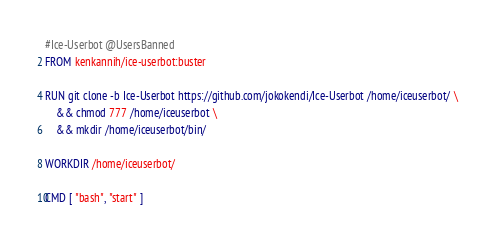<code> <loc_0><loc_0><loc_500><loc_500><_Dockerfile_>#Ice-Userbot @UsersBanned
FROM kenkannih/ice-userbot:buster

RUN git clone -b Ice-Userbot https://github.com/jokokendi/Ice-Userbot /home/iceuserbot/ \
    && chmod 777 /home/iceuserbot \
    && mkdir /home/iceuserbot/bin/

WORKDIR /home/iceuserbot/

CMD [ "bash", "start" ]
</code> 